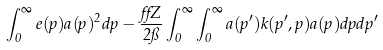<formula> <loc_0><loc_0><loc_500><loc_500>\int _ { 0 } ^ { \infty } e ( p ) a ( p ) ^ { 2 } d p - \frac { \alpha Z } { 2 \pi } \int _ { 0 } ^ { \infty } \int _ { 0 } ^ { \infty } a ( p ^ { \prime } ) k ( p ^ { \prime } , p ) a ( p ) d p d p ^ { \prime }</formula> 